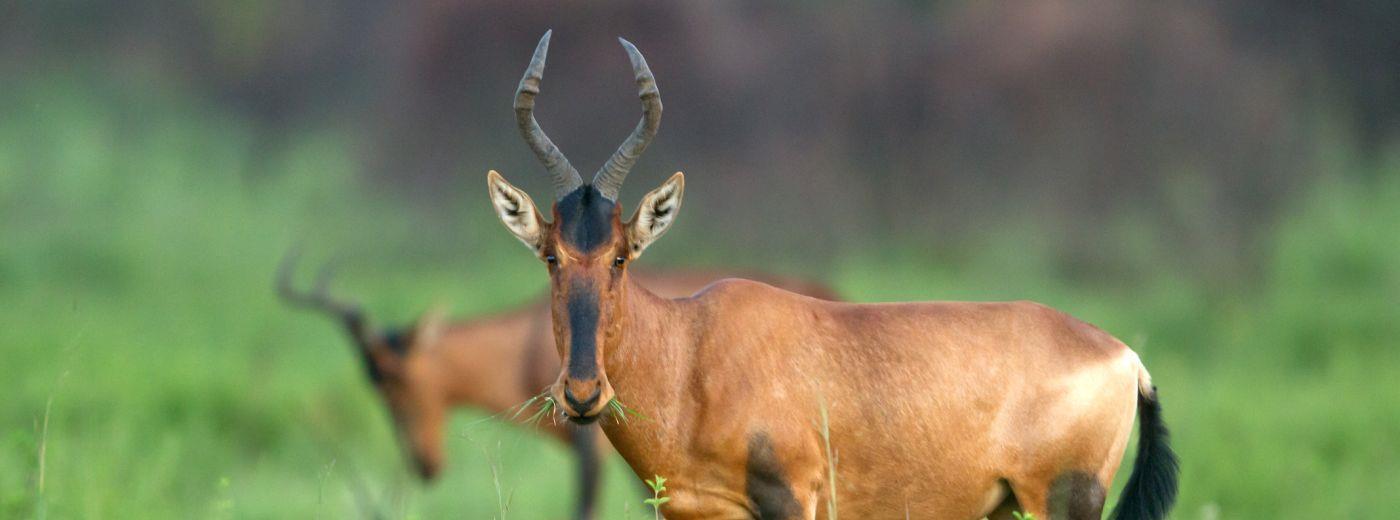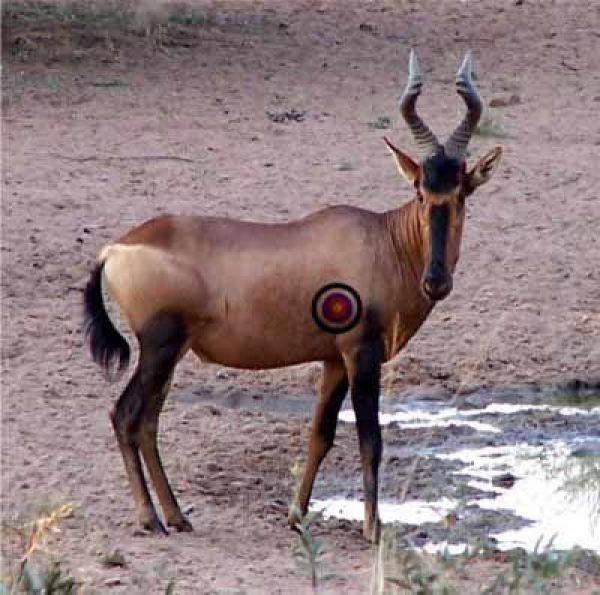The first image is the image on the left, the second image is the image on the right. For the images shown, is this caption "One of the animals has a red circle on it." true? Answer yes or no. Yes. The first image is the image on the left, the second image is the image on the right. Considering the images on both sides, is "There are two buffalo in total." valid? Answer yes or no. No. 